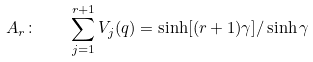Convert formula to latex. <formula><loc_0><loc_0><loc_500><loc_500>A _ { r } \colon \quad \sum _ { j = 1 } ^ { r + 1 } V _ { j } ( q ) = \sinh [ ( r + 1 ) \gamma ] / \sinh \gamma</formula> 